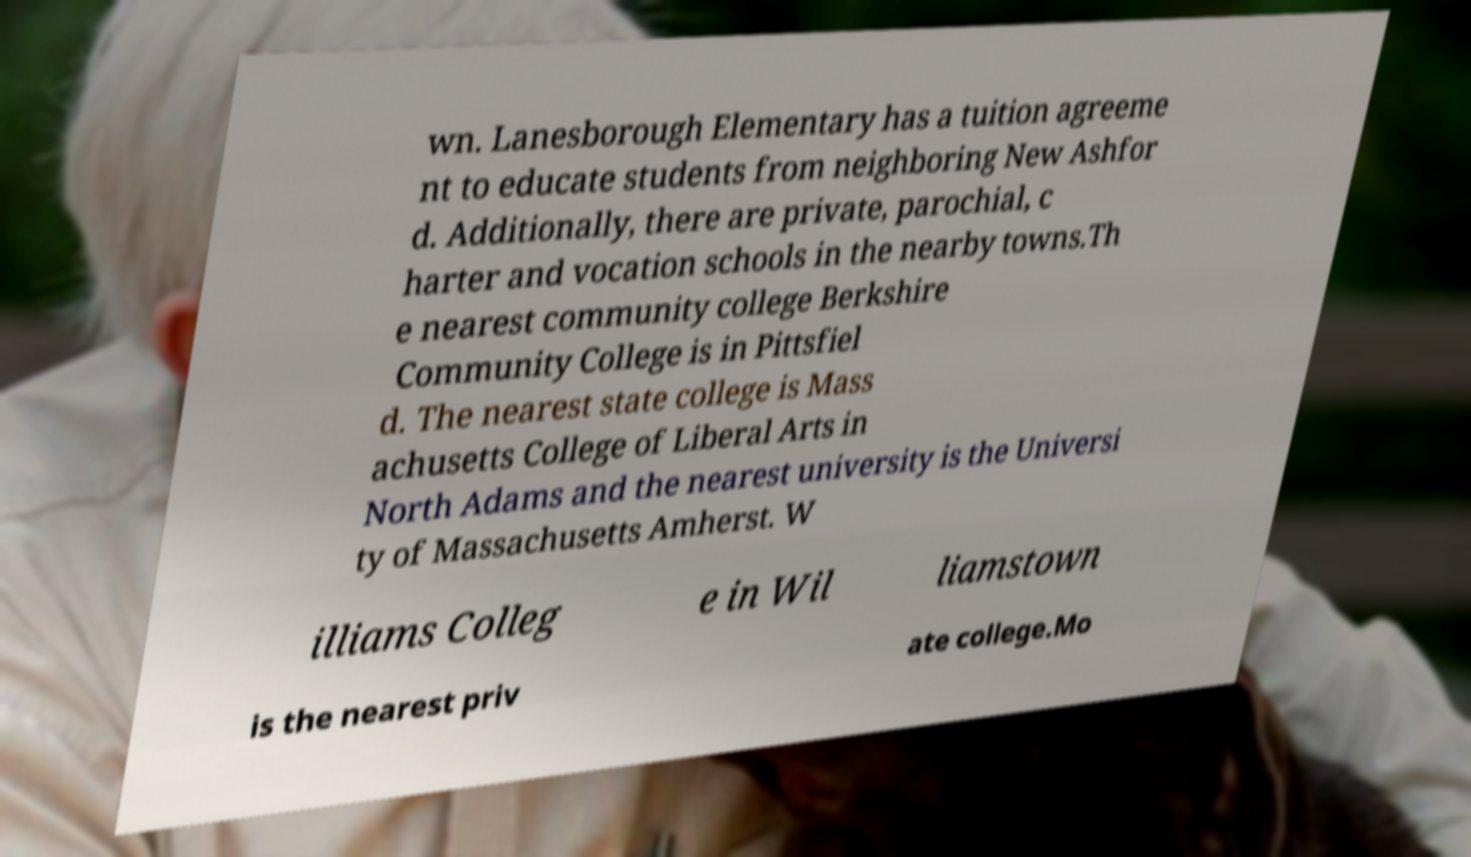For documentation purposes, I need the text within this image transcribed. Could you provide that? wn. Lanesborough Elementary has a tuition agreeme nt to educate students from neighboring New Ashfor d. Additionally, there are private, parochial, c harter and vocation schools in the nearby towns.Th e nearest community college Berkshire Community College is in Pittsfiel d. The nearest state college is Mass achusetts College of Liberal Arts in North Adams and the nearest university is the Universi ty of Massachusetts Amherst. W illiams Colleg e in Wil liamstown is the nearest priv ate college.Mo 